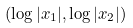<formula> <loc_0><loc_0><loc_500><loc_500>( \log | x _ { 1 } | , \log | x _ { 2 } | )</formula> 